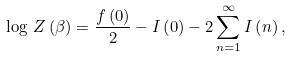<formula> <loc_0><loc_0><loc_500><loc_500>\log \, Z \left ( \beta \right ) = \frac { f \left ( 0 \right ) } { 2 } - I \left ( 0 \right ) - 2 \sum _ { n = 1 } ^ { \infty } I \left ( n \right ) ,</formula> 